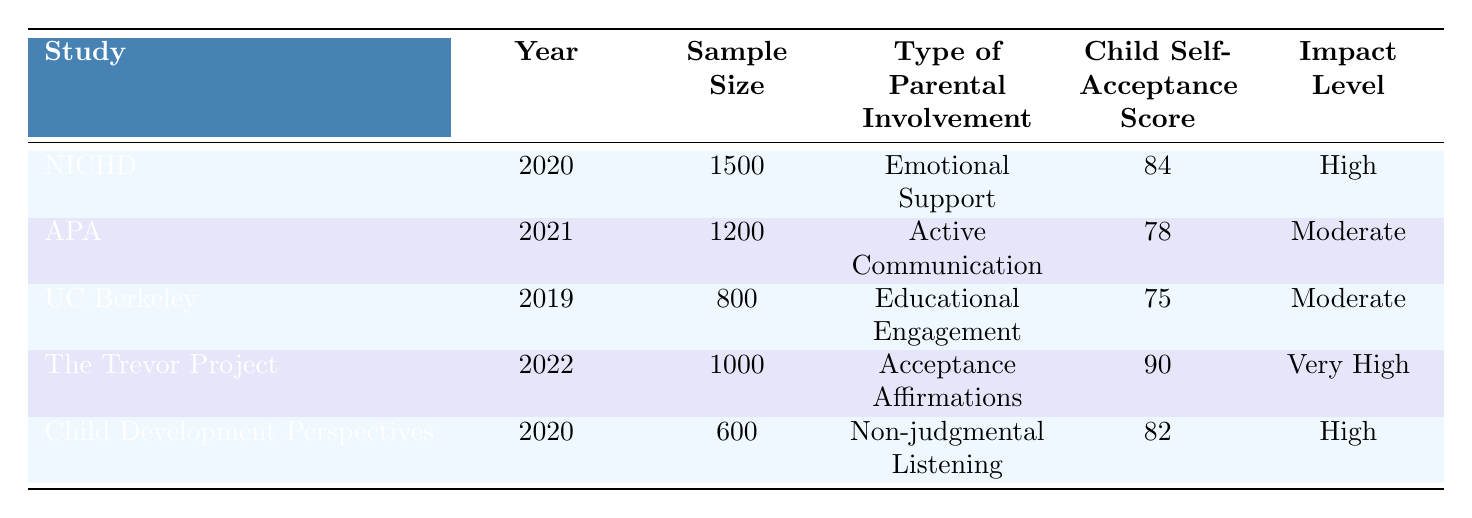What is the sample size of the study conducted by the American Psychological Association? The sample size of the American Psychological Association study is found in the table under the 'Sample Size' column for that specific study. It indicates a sample size of 1200.
Answer: 1200 What is the highest child self-acceptance score recorded in the table? To find the highest child self-acceptance score, we compare the 'Child Self-Acceptance Score' values from all studies. The highest score is 90 from The Trevor Project.
Answer: 90 Is the impact level of 'Emotional Support' categorized as high? The impact level for 'Emotional Support' is directly listed in the table, and it clearly states that the impact level is high.
Answer: Yes What is the average child self-acceptance score for the studies listed? The average score can be calculated by adding together all the self-acceptance scores (84 + 78 + 75 + 90 + 82 = 409) and dividing by the number of studies (5). Thus, the average score is 409 / 5 = 81.8.
Answer: 81.8 How many studies report a child self-acceptance score of 80 or above? We can filter the studies based on their self-acceptance scores. The studies that have scores of 80 or above are NICHD (84), The Trevor Project (90), and Child Development Perspectives (82), totaling 3 studies.
Answer: 3 What type of parental involvement had the lowest child self-acceptance score? By analyzing the 'Child Self-Acceptance Score' column, the lowest score is 75 from the study on Educational Engagement, indicating that this type had the lowest score.
Answer: Educational Engagement If the impact level is classified as very high, what is the corresponding type of parental involvement? The only type of parental involvement that has an impact level classified as very high is Acceptance Affirmations from The Trevor Project study.
Answer: Acceptance Affirmations Which year saw the highest child self-acceptance score, and how much was it? The table shows The Trevor Project study in 2022 had the highest child self-acceptance score of 90, making it clear that 2022 is the year with the highest score.
Answer: 2022, 90 